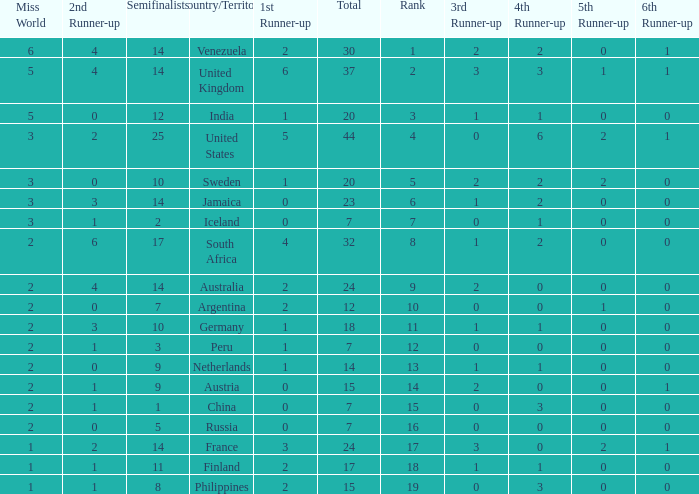What is Iceland's total? 1.0. 